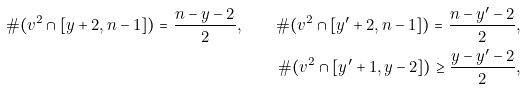Convert formula to latex. <formula><loc_0><loc_0><loc_500><loc_500>\# ( v ^ { 2 } \cap [ y + 2 , n - 1 ] ) = \frac { n - y - 2 } { 2 } , \quad \# ( v ^ { 2 } \cap [ y ^ { \prime } + 2 , n - 1 ] ) = \frac { n - y ^ { \prime } - 2 } { 2 } , \\ \# ( v ^ { 2 } \cap [ y ^ { \prime } + 1 , y - 2 ] ) \geq \frac { y - y ^ { \prime } - 2 } { 2 } ,</formula> 